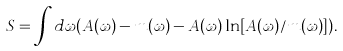Convert formula to latex. <formula><loc_0><loc_0><loc_500><loc_500>S = \int d \omega ( A ( \omega ) - m ( \omega ) - A ( \omega ) \ln [ A ( \omega ) / m ( \omega ) ] ) .</formula> 